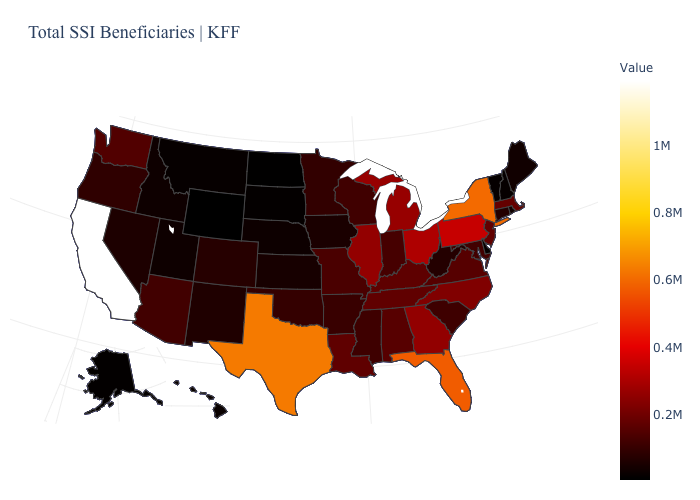Which states hav the highest value in the South?
Answer briefly. Texas. Which states hav the highest value in the MidWest?
Write a very short answer. Ohio. Does Arkansas have the lowest value in the USA?
Keep it brief. No. Among the states that border Illinois , does Wisconsin have the lowest value?
Give a very brief answer. No. Is the legend a continuous bar?
Quick response, please. Yes. Which states have the lowest value in the MidWest?
Keep it brief. North Dakota. 